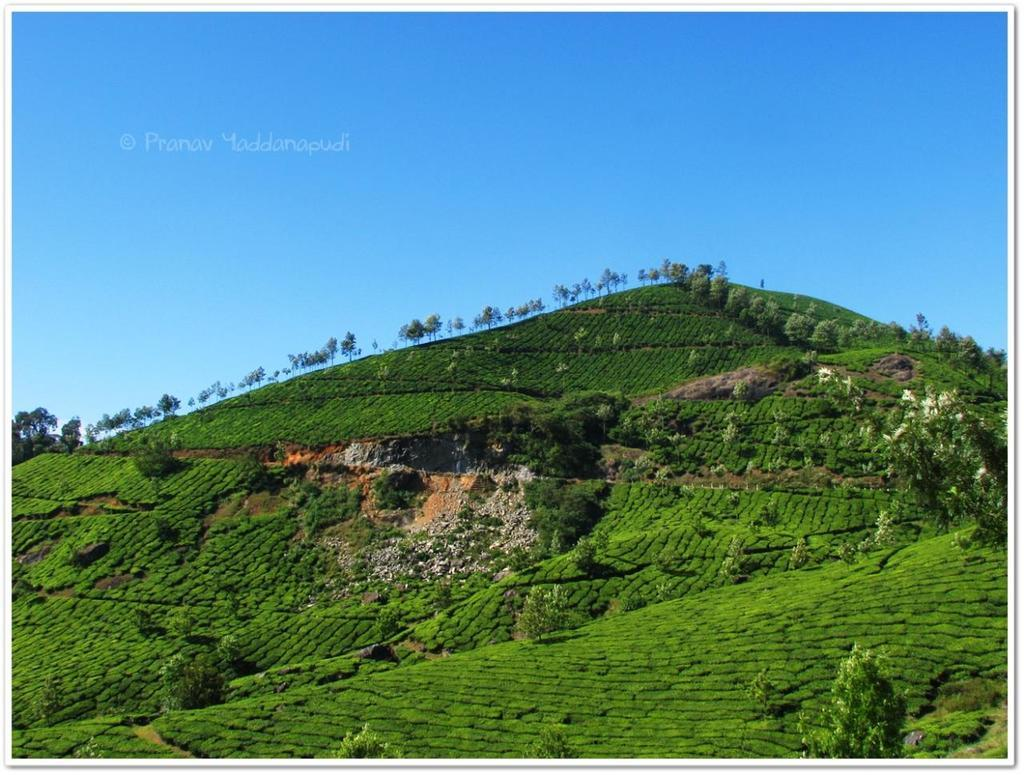What geographical feature is present in the image? There is a hill in the image. What can be found on the hill? The hill has plants and trees on it. What is visible above the hill? The sky is visible above the hill. What is the income of the horse grazing on the hill in the image? There is no horse present in the image, so it is not possible to determine its income. 